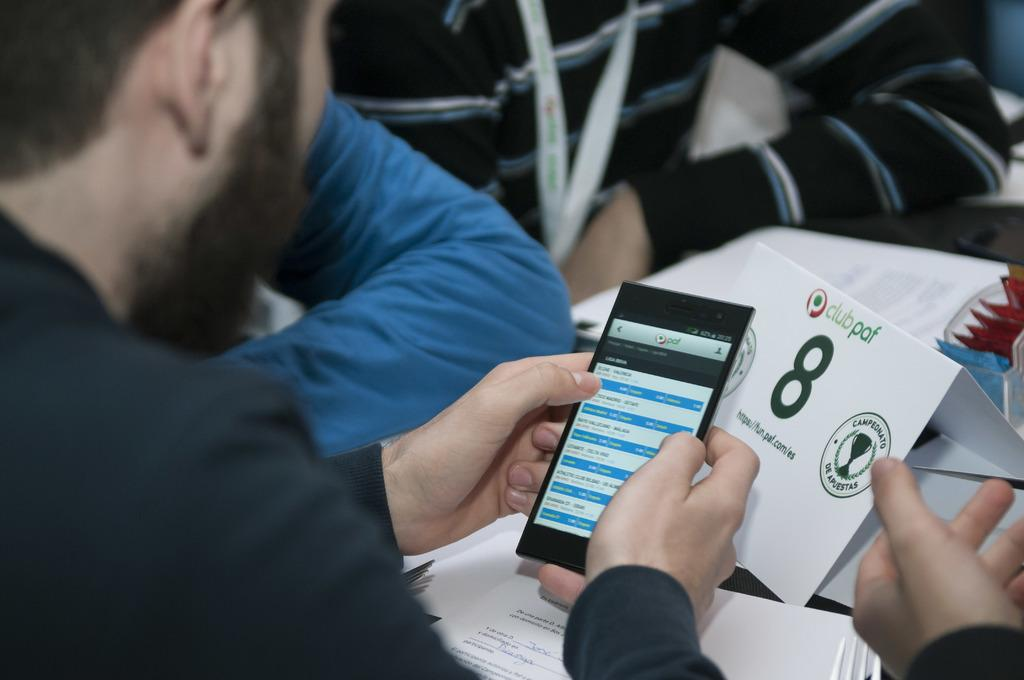How many people are present in the image? There are three persons in the image. What is one of the persons holding? One of the persons is holding a mobile. What else can be seen in the image besides the people? There are papers in the image. What type of cave can be seen in the background of the image? There is no cave present in the image. How many times has the story been folded in the image? There is no story present in the image, so it cannot be folded. 